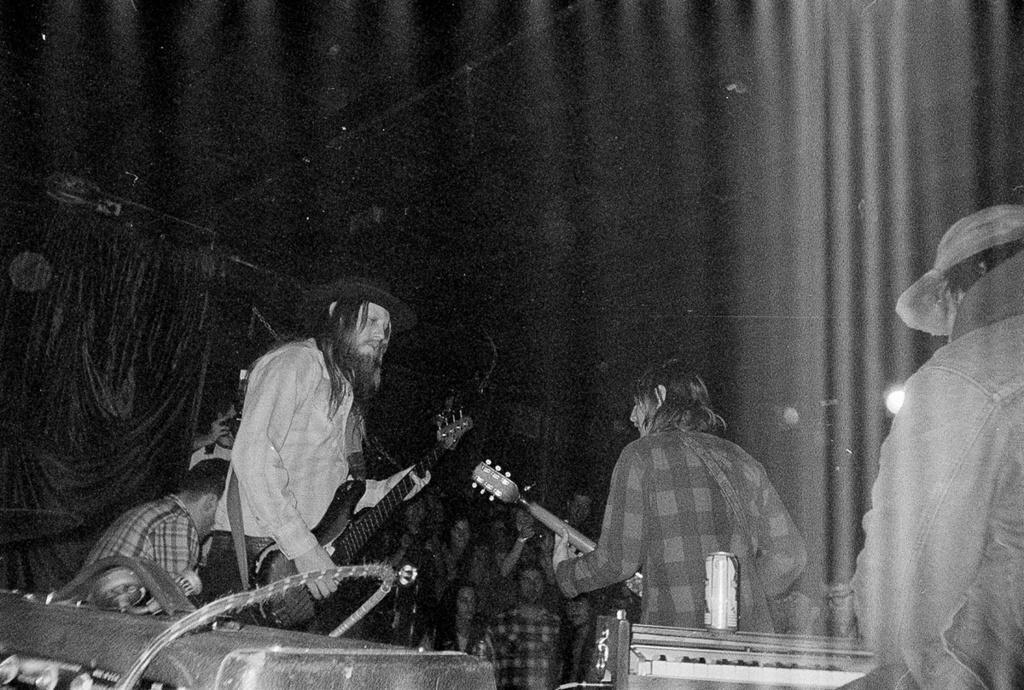Please provide a concise description of this image. In this image, in the left side there is a man standing and he is holding a guitar which is in black color, in the middle there is a person standing and holding a music instrument, in the right side there is a man standing and in the background there are some people standing. 